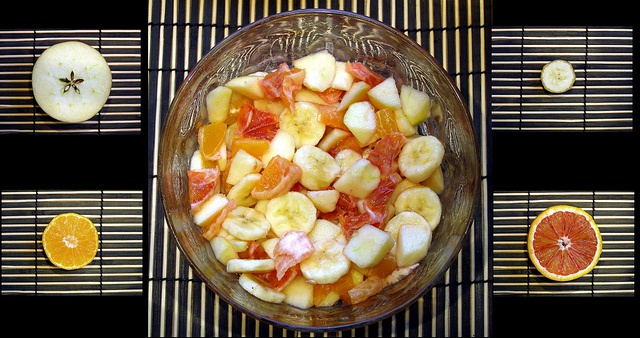Describe the objects in this image and their specific colors. I can see bowl in black, olive, khaki, lightgray, and brown tones, apple in black, beige, and darkgray tones, orange in black, red, brown, salmon, and ivory tones, banana in black and tan tones, and banana in black, khaki, beige, tan, and orange tones in this image. 